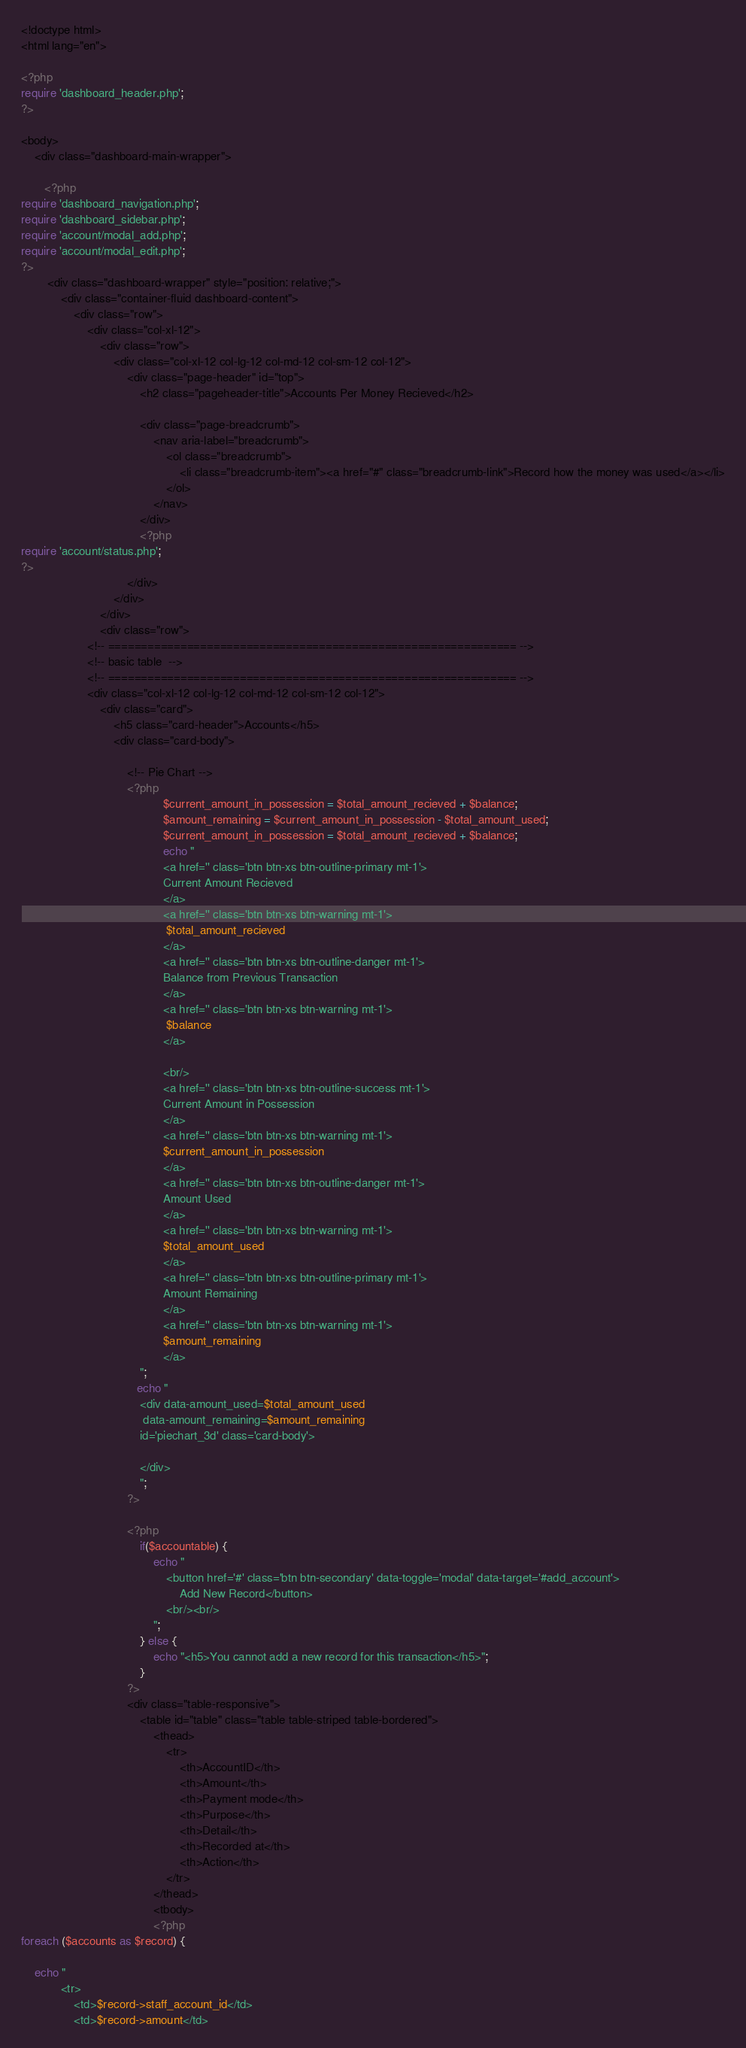Convert code to text. <code><loc_0><loc_0><loc_500><loc_500><_PHP_><!doctype html>
<html lang="en">

<?php
require 'dashboard_header.php';
?>

<body>
    <div class="dashboard-main-wrapper">

       <?php
require 'dashboard_navigation.php';
require 'dashboard_sidebar.php';
require 'account/modal_add.php';
require 'account/modal_edit.php';
?>
        <div class="dashboard-wrapper" style="position: relative;">
            <div class="container-fluid dashboard-content">
                <div class="row">
                    <div class="col-xl-12">
                        <div class="row">
                            <div class="col-xl-12 col-lg-12 col-md-12 col-sm-12 col-12">
                                <div class="page-header" id="top">
                                    <h2 class="pageheader-title">Accounts Per Money Recieved</h2>

                                    <div class="page-breadcrumb">
                                        <nav aria-label="breadcrumb">
                                            <ol class="breadcrumb">
                                                <li class="breadcrumb-item"><a href="#" class="breadcrumb-link">Record how the money was used</a></li>
                                            </ol>
                                        </nav>
                                    </div>
                                    <?php
require 'account/status.php';
?>
                                </div>
                            </div>
                        </div>
                        <div class="row">
                    <!-- ============================================================== -->
                    <!-- basic table  -->
                    <!-- ============================================================== -->
                    <div class="col-xl-12 col-lg-12 col-md-12 col-sm-12 col-12">
                        <div class="card">
                            <h5 class="card-header">Accounts</h5>
                            <div class="card-body">

                                <!-- Pie Chart -->
                                <?php 
                                           $current_amount_in_possession = $total_amount_recieved + $balance;
                                           $amount_remaining = $current_amount_in_possession - $total_amount_used;
                                           $current_amount_in_possession = $total_amount_recieved + $balance;
                                           echo "
                                           <a href='' class='btn btn-xs btn-outline-primary mt-1'>
                                           Current Amount Recieved
                                           </a>
                                           <a href='' class='btn btn-xs btn-warning mt-1'>
                                            $total_amount_recieved
                                           </a>
                                           <a href='' class='btn btn-xs btn-outline-danger mt-1'>
                                           Balance from Previous Transaction
                                           </a>
                                           <a href='' class='btn btn-xs btn-warning mt-1'>
                                            $balance
                                           </a>
                                          
                                           <br/>
                                           <a href='' class='btn btn-xs btn-outline-success mt-1'>
                                           Current Amount in Possession
                                           </a>
                                           <a href='' class='btn btn-xs btn-warning mt-1'>
                                           $current_amount_in_possession
                                           </a>
                                           <a href='' class='btn btn-xs btn-outline-danger mt-1'>
                                           Amount Used
                                           </a>
                                           <a href='' class='btn btn-xs btn-warning mt-1'>
                                           $total_amount_used
                                           </a>
                                           <a href='' class='btn btn-xs btn-outline-primary mt-1'>
                                           Amount Remaining
                                           </a>
                                           <a href='' class='btn btn-xs btn-warning mt-1'>
                                           $amount_remaining
                                           </a>
                                    ";
                                   echo "
                                    <div data-amount_used=$total_amount_used 
                                     data-amount_remaining=$amount_remaining
                                    id='piechart_3d' class='card-body'>
                                   
                                    </div>
                                    ";
                                ?>
                                
                                <?php
                                    if($accountable) {
                                        echo "
                                            <button href='#' class='btn btn-secondary' data-toggle='modal' data-target='#add_account'>
                                                Add New Record</button>
                                            <br/><br/>
                                        ";    
                                    } else {
                                        echo "<h5>You cannot add a new record for this transaction</h5>";
                                    }
                                ?>
                                <div class="table-responsive">
                                    <table id="table" class="table table-striped table-bordered">
                                        <thead>
                                            <tr>
                                                <th>AccountID</th>
                                                <th>Amount</th>
                                                <th>Payment mode</th>
                                                <th>Purpose</th>
                                                <th>Detail</th>
                                                <th>Recorded at</th>
                                                <th>Action</th>
                                            </tr>
                                        </thead>
                                        <tbody>
                                        <?php
foreach ($accounts as $record) {

    echo "
            <tr>
                <td>$record->staff_account_id</td>
                <td>$record->amount</td></code> 